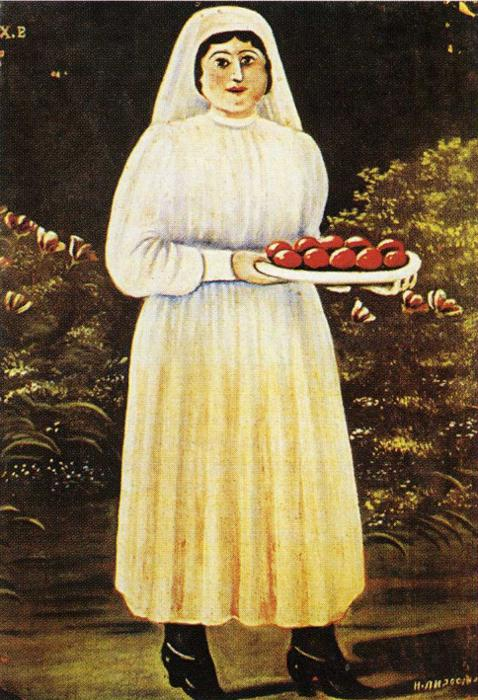What is this photo about? The image beautifully captures a folk art painting. In this vivid portrayal, a woman with a serene and direct gaze is central against a dark forest backdrop. She stands in traditional attire, a white dress and headscarf, which brighten her silhouette amid the darker tones. She holds a tray heavy with ripe, red apples, symbolizing perhaps a time of harvest and the richness of nature's bounty. Behind her, a lively tree blooms with red flowers against its dark branches, adding a touch of vibrancy. Each element from the bright red of the apples and flowers to the solemn dark background contributes to a contrast that highlights themes of fertility, abundance, and maybe folklore. The signature 'H.H. 26/6' perhaps dates the painting or indicates the artist's name, adding a layer of mystery and historical context to the work. 